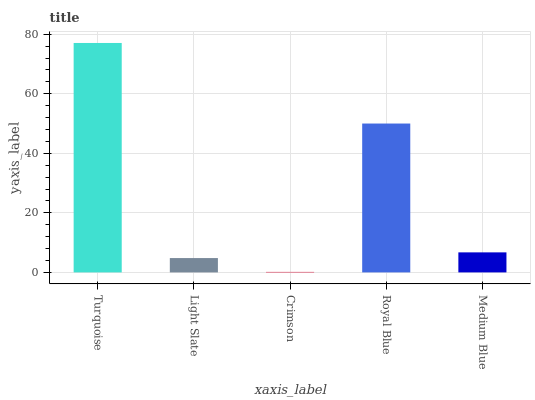Is Crimson the minimum?
Answer yes or no. Yes. Is Turquoise the maximum?
Answer yes or no. Yes. Is Light Slate the minimum?
Answer yes or no. No. Is Light Slate the maximum?
Answer yes or no. No. Is Turquoise greater than Light Slate?
Answer yes or no. Yes. Is Light Slate less than Turquoise?
Answer yes or no. Yes. Is Light Slate greater than Turquoise?
Answer yes or no. No. Is Turquoise less than Light Slate?
Answer yes or no. No. Is Medium Blue the high median?
Answer yes or no. Yes. Is Medium Blue the low median?
Answer yes or no. Yes. Is Turquoise the high median?
Answer yes or no. No. Is Light Slate the low median?
Answer yes or no. No. 